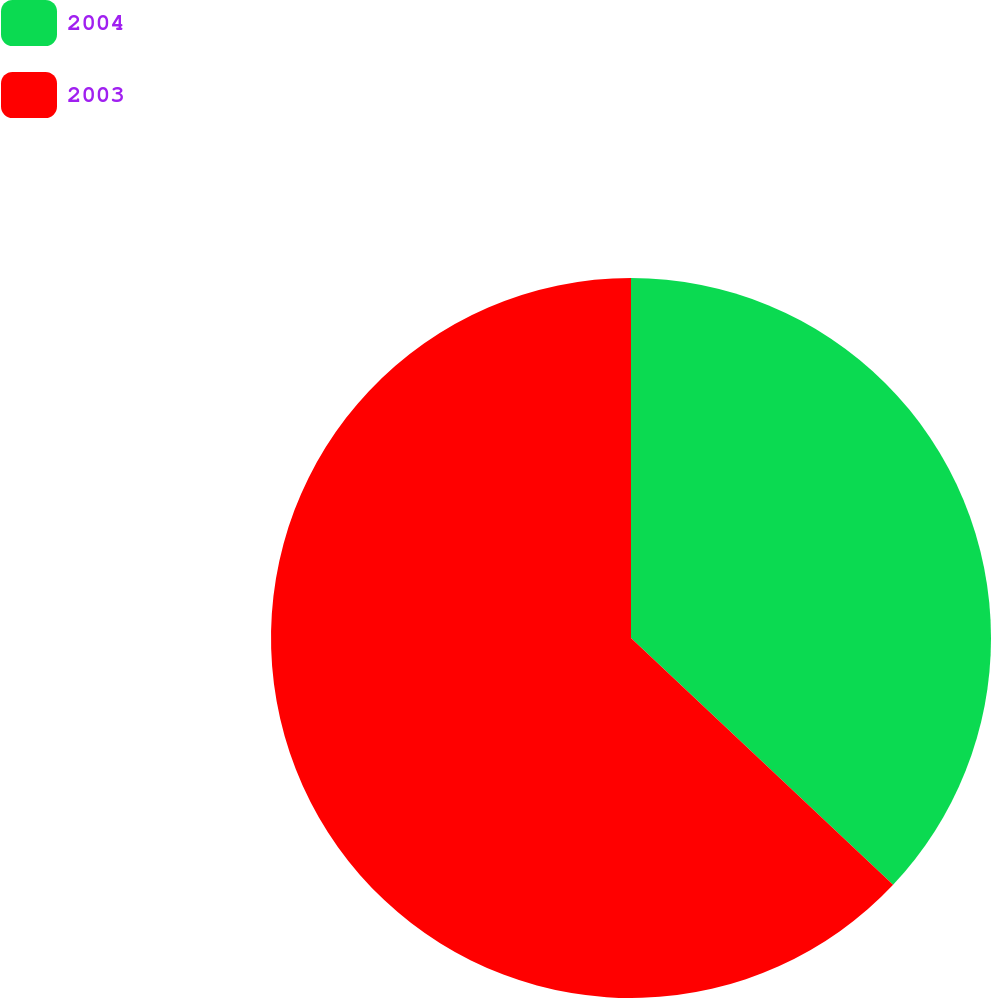<chart> <loc_0><loc_0><loc_500><loc_500><pie_chart><fcel>2004<fcel>2003<nl><fcel>37.02%<fcel>62.98%<nl></chart> 